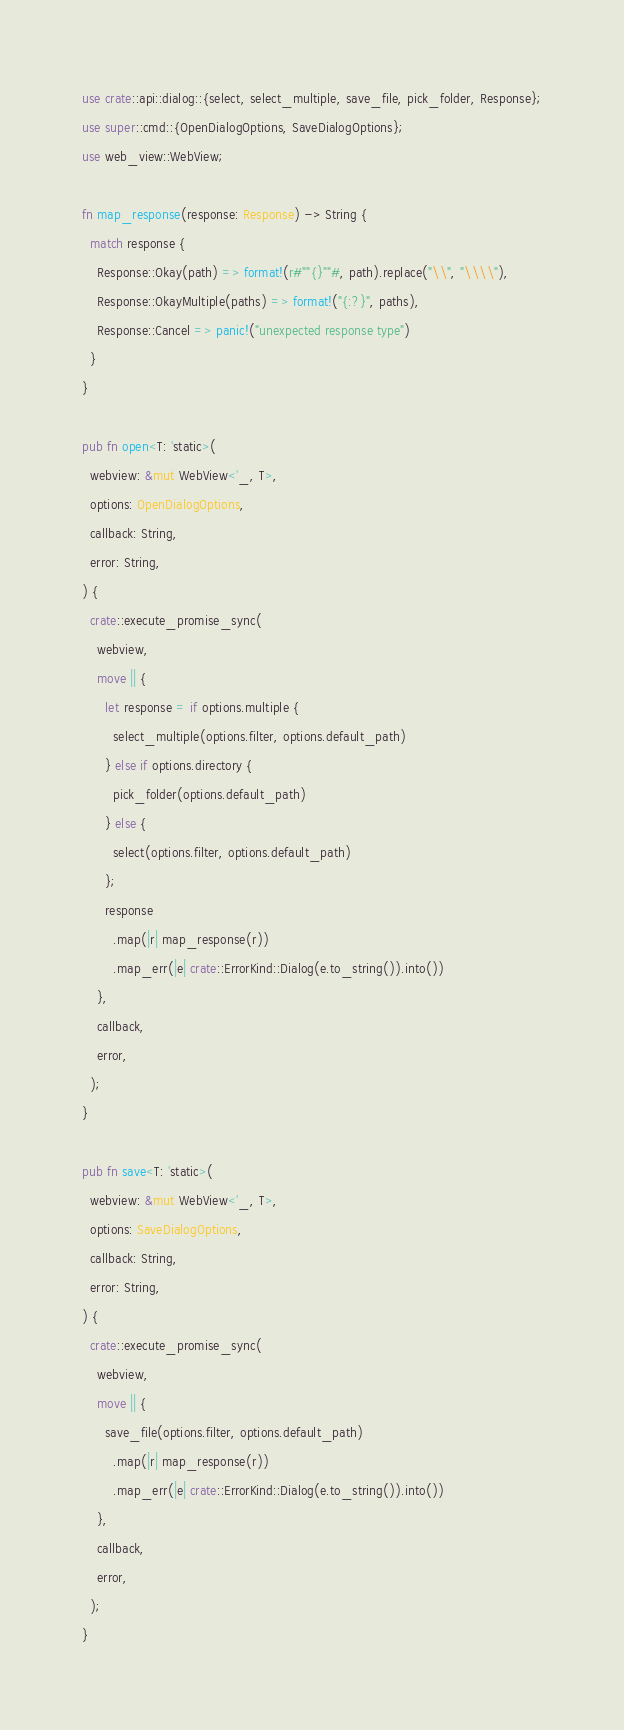Convert code to text. <code><loc_0><loc_0><loc_500><loc_500><_Rust_>use crate::api::dialog::{select, select_multiple, save_file, pick_folder, Response};
use super::cmd::{OpenDialogOptions, SaveDialogOptions};
use web_view::WebView;

fn map_response(response: Response) -> String {
  match response {
    Response::Okay(path) => format!(r#""{}""#, path).replace("\\", "\\\\"),
    Response::OkayMultiple(paths) => format!("{:?}", paths),
    Response::Cancel => panic!("unexpected response type")
  }
}

pub fn open<T: 'static>(
  webview: &mut WebView<'_, T>,
  options: OpenDialogOptions,
  callback: String,
  error: String,
) {
  crate::execute_promise_sync(
    webview,
    move || {
      let response = if options.multiple {
        select_multiple(options.filter, options.default_path)
      } else if options.directory {
        pick_folder(options.default_path)
      } else {
        select(options.filter, options.default_path)
      };
      response
        .map(|r| map_response(r))
        .map_err(|e| crate::ErrorKind::Dialog(e.to_string()).into())
    },
    callback,
    error,
  );
}

pub fn save<T: 'static>(
  webview: &mut WebView<'_, T>,
  options: SaveDialogOptions,
  callback: String,
  error: String,
) {
  crate::execute_promise_sync(
    webview,
    move || {
      save_file(options.filter, options.default_path)
        .map(|r| map_response(r))
        .map_err(|e| crate::ErrorKind::Dialog(e.to_string()).into())
    },
    callback,
    error,
  );
}</code> 